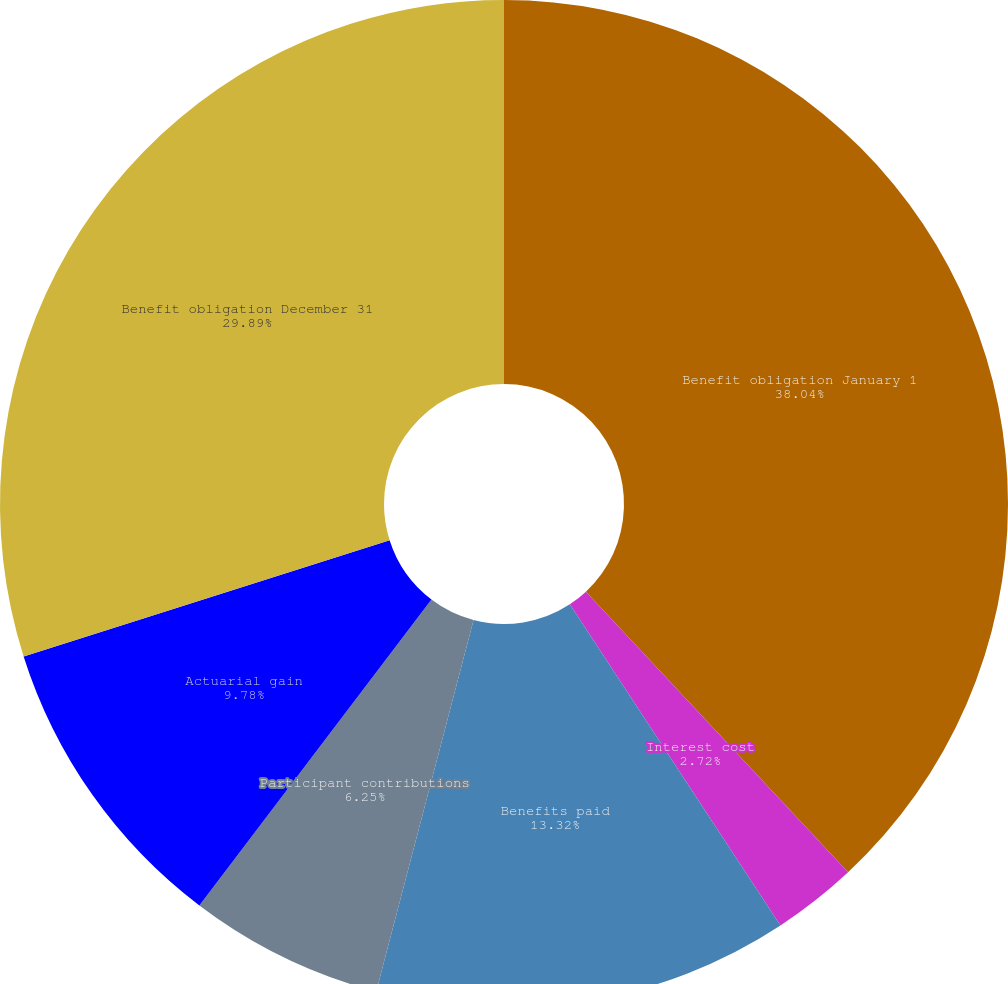Convert chart. <chart><loc_0><loc_0><loc_500><loc_500><pie_chart><fcel>Benefit obligation January 1<fcel>Interest cost<fcel>Benefits paid<fcel>Participant contributions<fcel>Actuarial gain<fcel>Benefit obligation December 31<nl><fcel>38.04%<fcel>2.72%<fcel>13.32%<fcel>6.25%<fcel>9.78%<fcel>29.89%<nl></chart> 